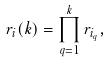Convert formula to latex. <formula><loc_0><loc_0><loc_500><loc_500>r _ { i } ( k ) = \prod _ { q = 1 } ^ { k } r _ { i _ { q } } ,</formula> 